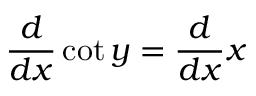<formula> <loc_0><loc_0><loc_500><loc_500>{ \frac { d } { d x } } \cot y = { \frac { d } { d x } } x</formula> 